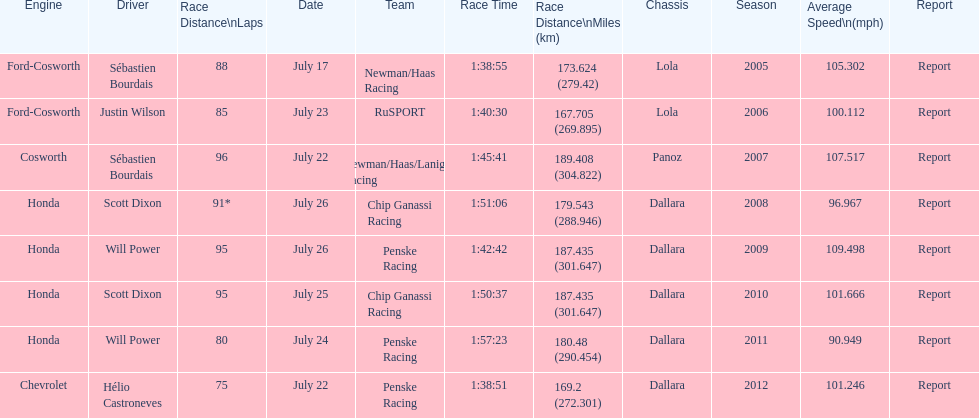How many times did sébastien bourdais win the champ car world series between 2005 and 2007? 2. 